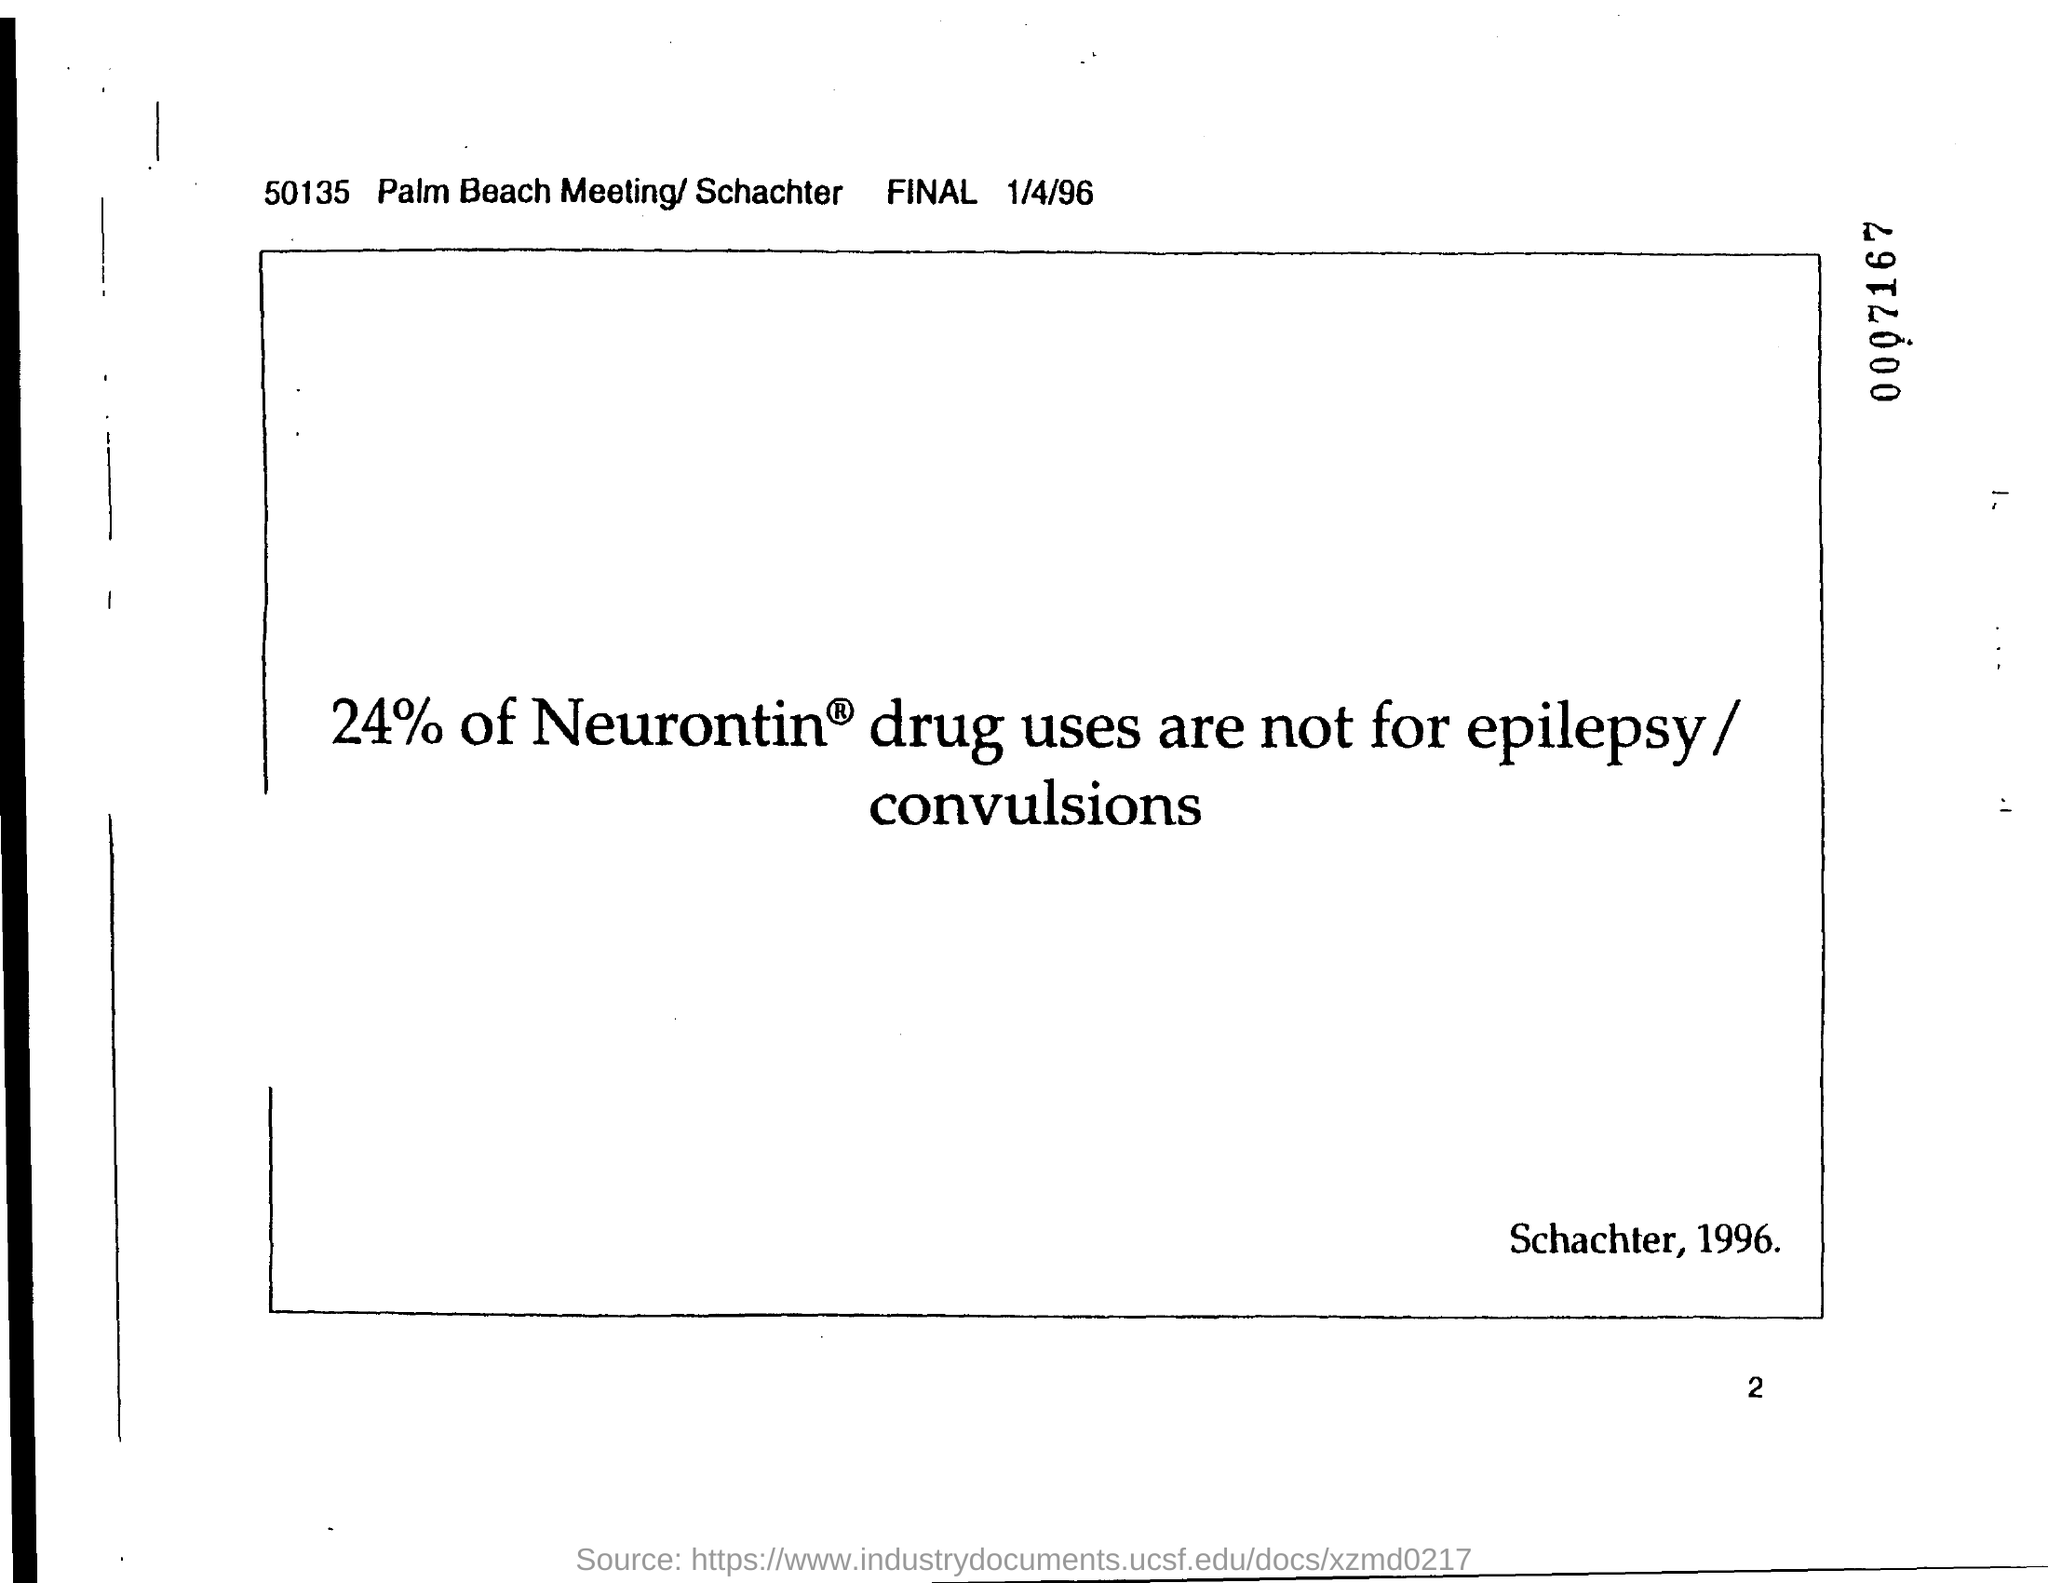What is the date?
Offer a terse response. 1/4/96. What percent of Neurontin is mentioned?
Your response must be concise. 24. 